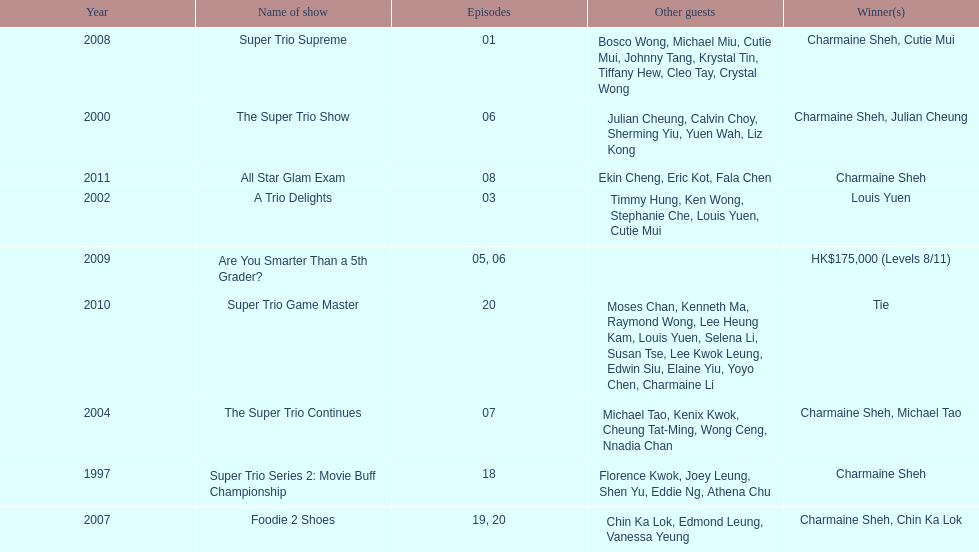What was the total number of trio series shows were charmaine sheh on? 6. 